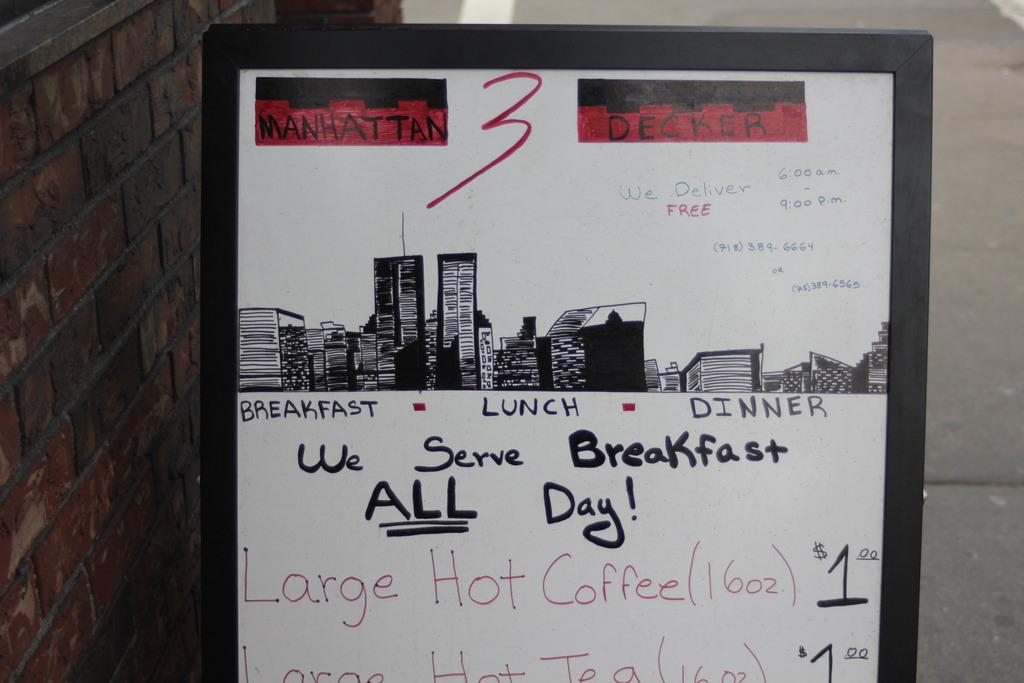<image>
Write a terse but informative summary of the picture. The cafe advertises the fact that they serve breakfast ALL day. 